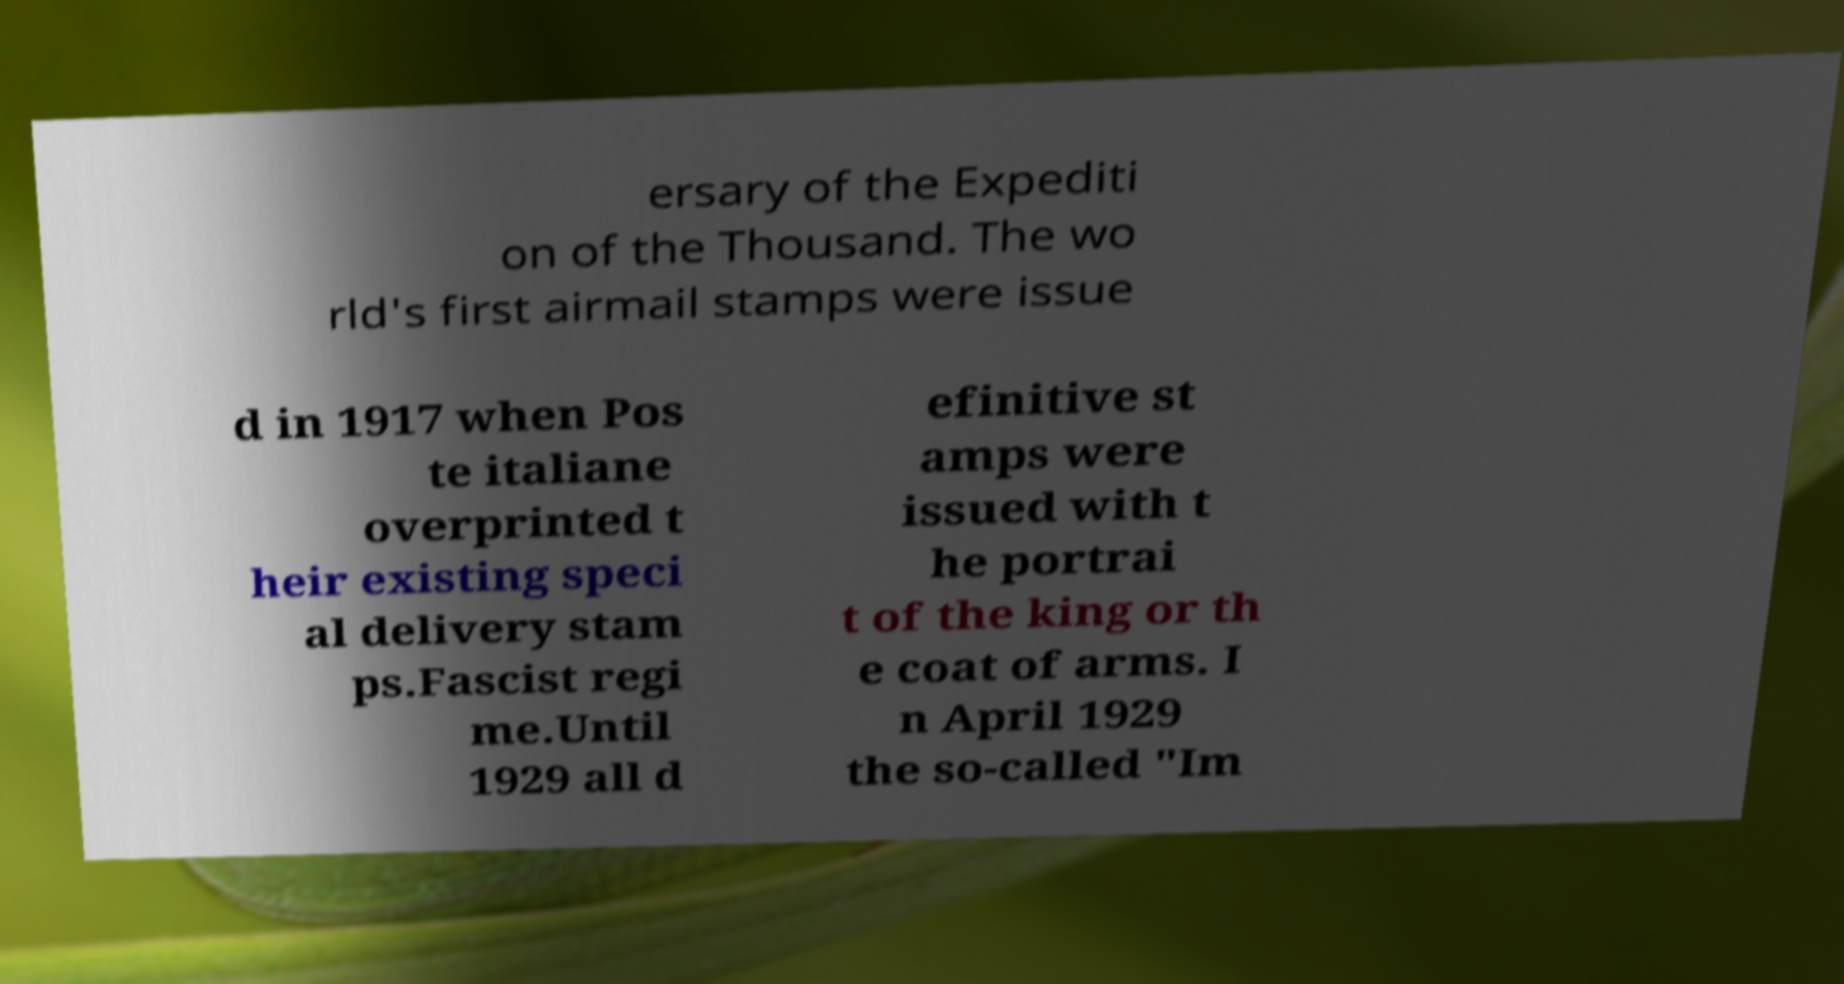What messages or text are displayed in this image? I need them in a readable, typed format. ersary of the Expediti on of the Thousand. The wo rld's first airmail stamps were issue d in 1917 when Pos te italiane overprinted t heir existing speci al delivery stam ps.Fascist regi me.Until 1929 all d efinitive st amps were issued with t he portrai t of the king or th e coat of arms. I n April 1929 the so-called "Im 